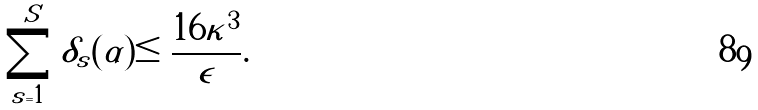<formula> <loc_0><loc_0><loc_500><loc_500>\sum _ { s = 1 } ^ { S } \delta _ { s } ( \alpha ) \leq \frac { 1 6 \kappa ^ { 3 } } { \epsilon } .</formula> 